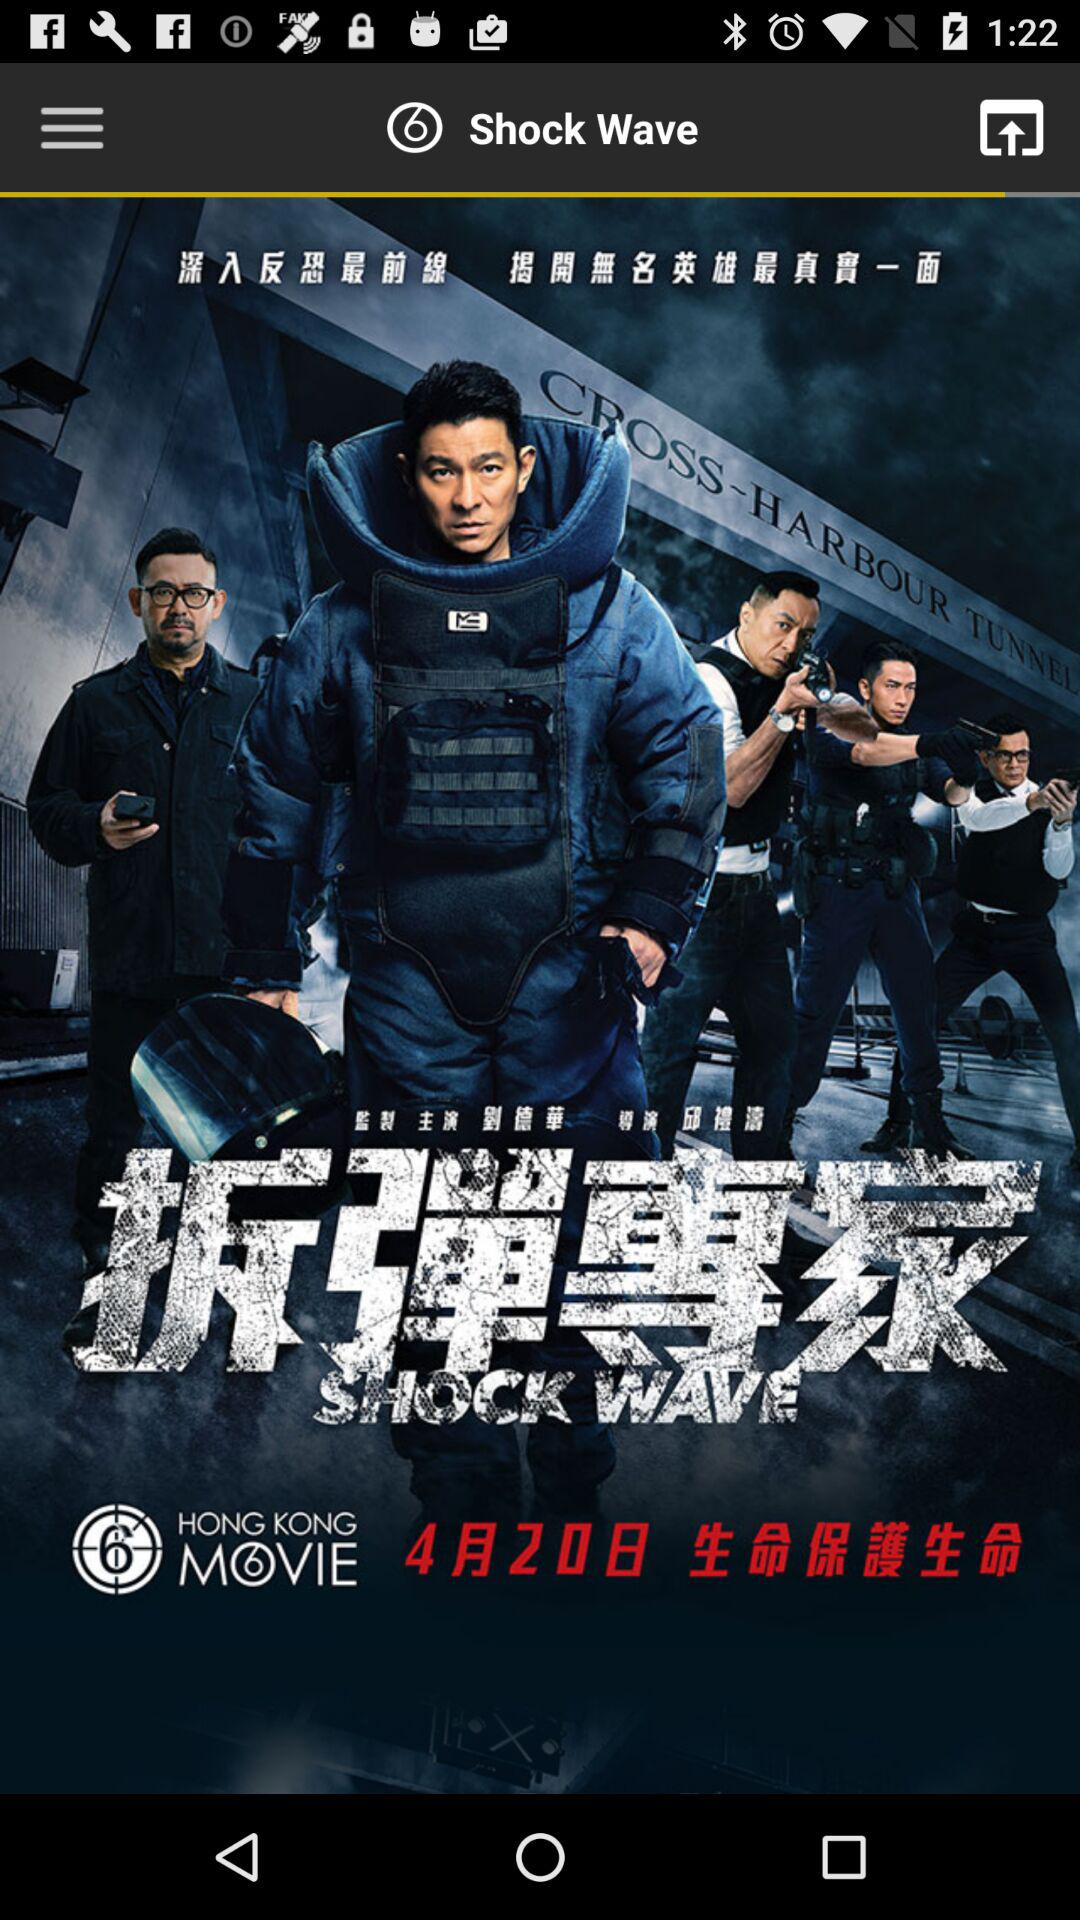What is the name of the movie? The name of the movie is "Shock Wave". 